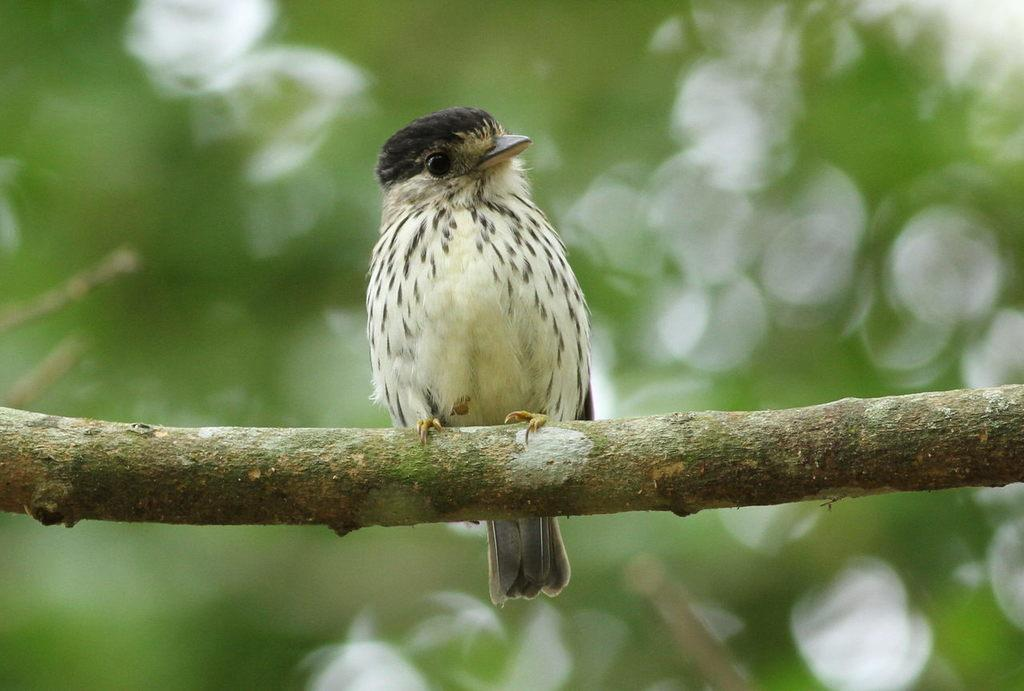What type of animal can be seen in the image? There is a bird in the image. Where is the bird located? The bird is on a stem. In which direction is the bird looking? The bird is looking to the right side. Can you describe the background of the image? The background of the image is blurred. What type of shirt is the bird wearing in the image? Birds do not wear shirts, so there is no shirt present in the image. Can you recite the verse that the bird is singing in the image? There is no indication that the bird is singing or reciting a verse in the image. 